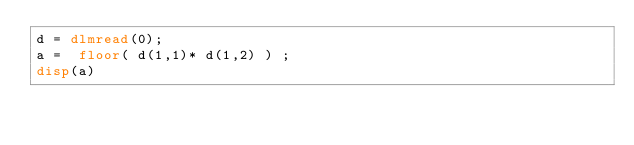Convert code to text. <code><loc_0><loc_0><loc_500><loc_500><_Octave_>d = dlmread(0);
a =  floor( d(1,1)* d(1,2) ) ;
disp(a)</code> 